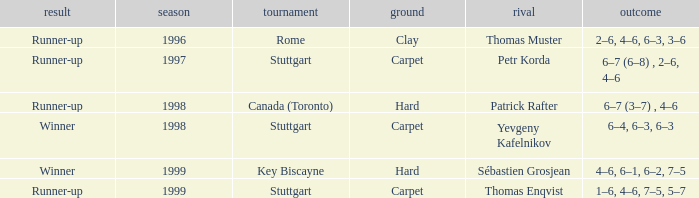Could you parse the entire table as a dict? {'header': ['result', 'season', 'tournament', 'ground', 'rival', 'outcome'], 'rows': [['Runner-up', '1996', 'Rome', 'Clay', 'Thomas Muster', '2–6, 4–6, 6–3, 3–6'], ['Runner-up', '1997', 'Stuttgart', 'Carpet', 'Petr Korda', '6–7 (6–8) , 2–6, 4–6'], ['Runner-up', '1998', 'Canada (Toronto)', 'Hard', 'Patrick Rafter', '6–7 (3–7) , 4–6'], ['Winner', '1998', 'Stuttgart', 'Carpet', 'Yevgeny Kafelnikov', '6–4, 6–3, 6–3'], ['Winner', '1999', 'Key Biscayne', 'Hard', 'Sébastien Grosjean', '4–6, 6–1, 6–2, 7–5'], ['Runner-up', '1999', 'Stuttgart', 'Carpet', 'Thomas Enqvist', '1–6, 4–6, 7–5, 5–7']]} What championship after 1997 was the score 1–6, 4–6, 7–5, 5–7? Stuttgart. 